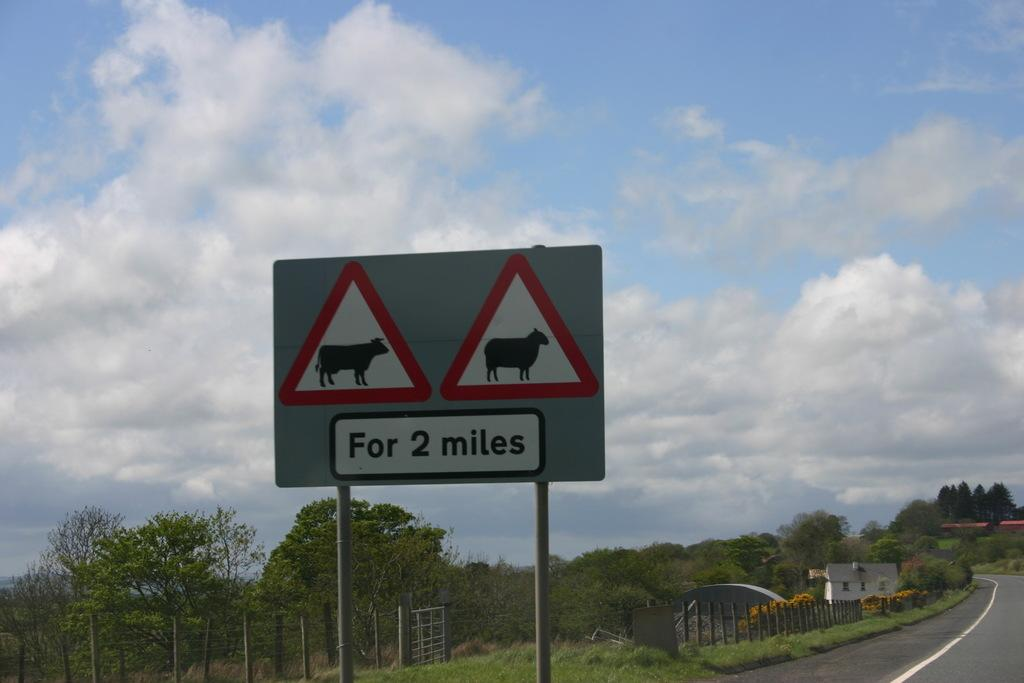<image>
Describe the image concisely. Signs warn of cows and sheep on the road for two miles. 